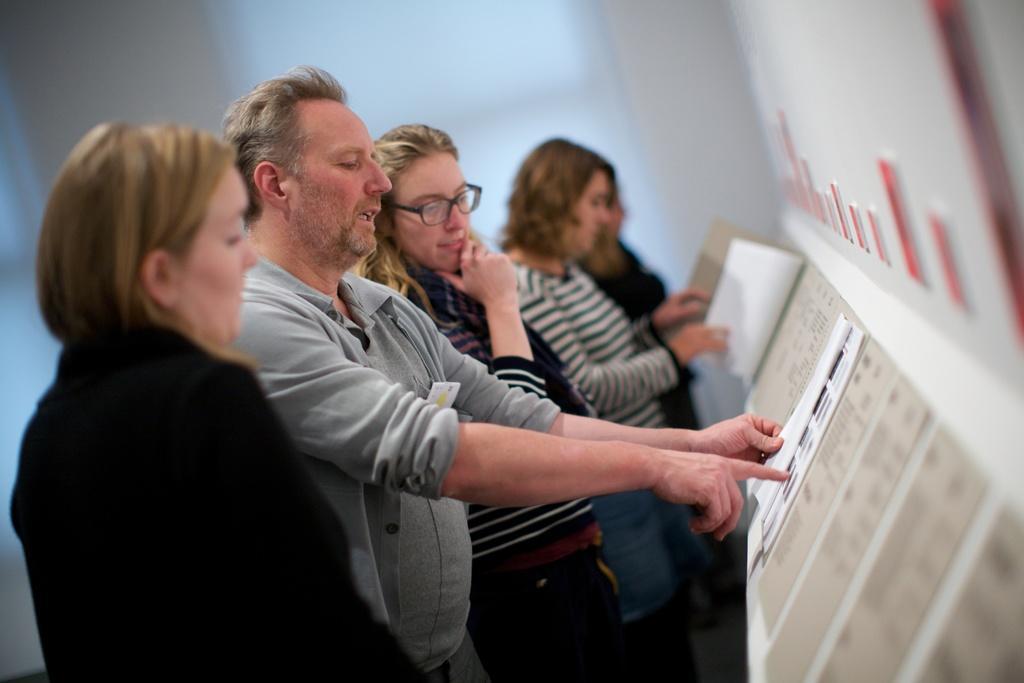Please provide a concise description of this image. In this image I can see one man and few women are standing. I can also see one of them is wearing specs. Here I can see number of papers and on these papers I can see something is written. I can also see this image is little bit blurry. 